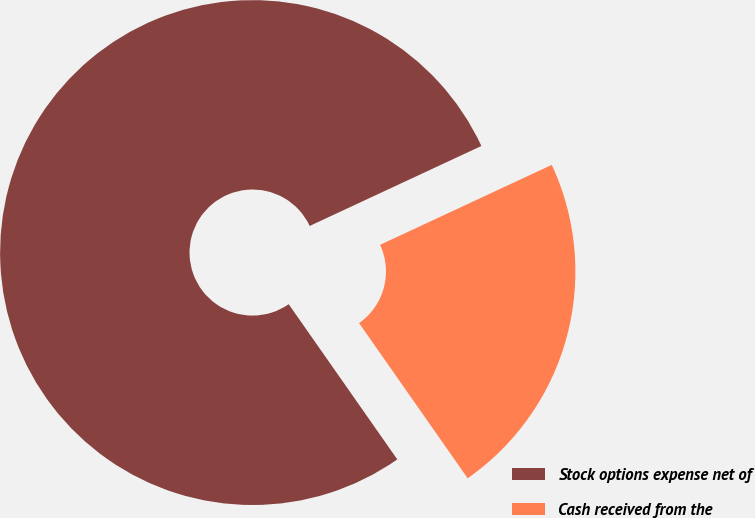Convert chart to OTSL. <chart><loc_0><loc_0><loc_500><loc_500><pie_chart><fcel>Stock options expense net of<fcel>Cash received from the<nl><fcel>77.78%<fcel>22.22%<nl></chart> 